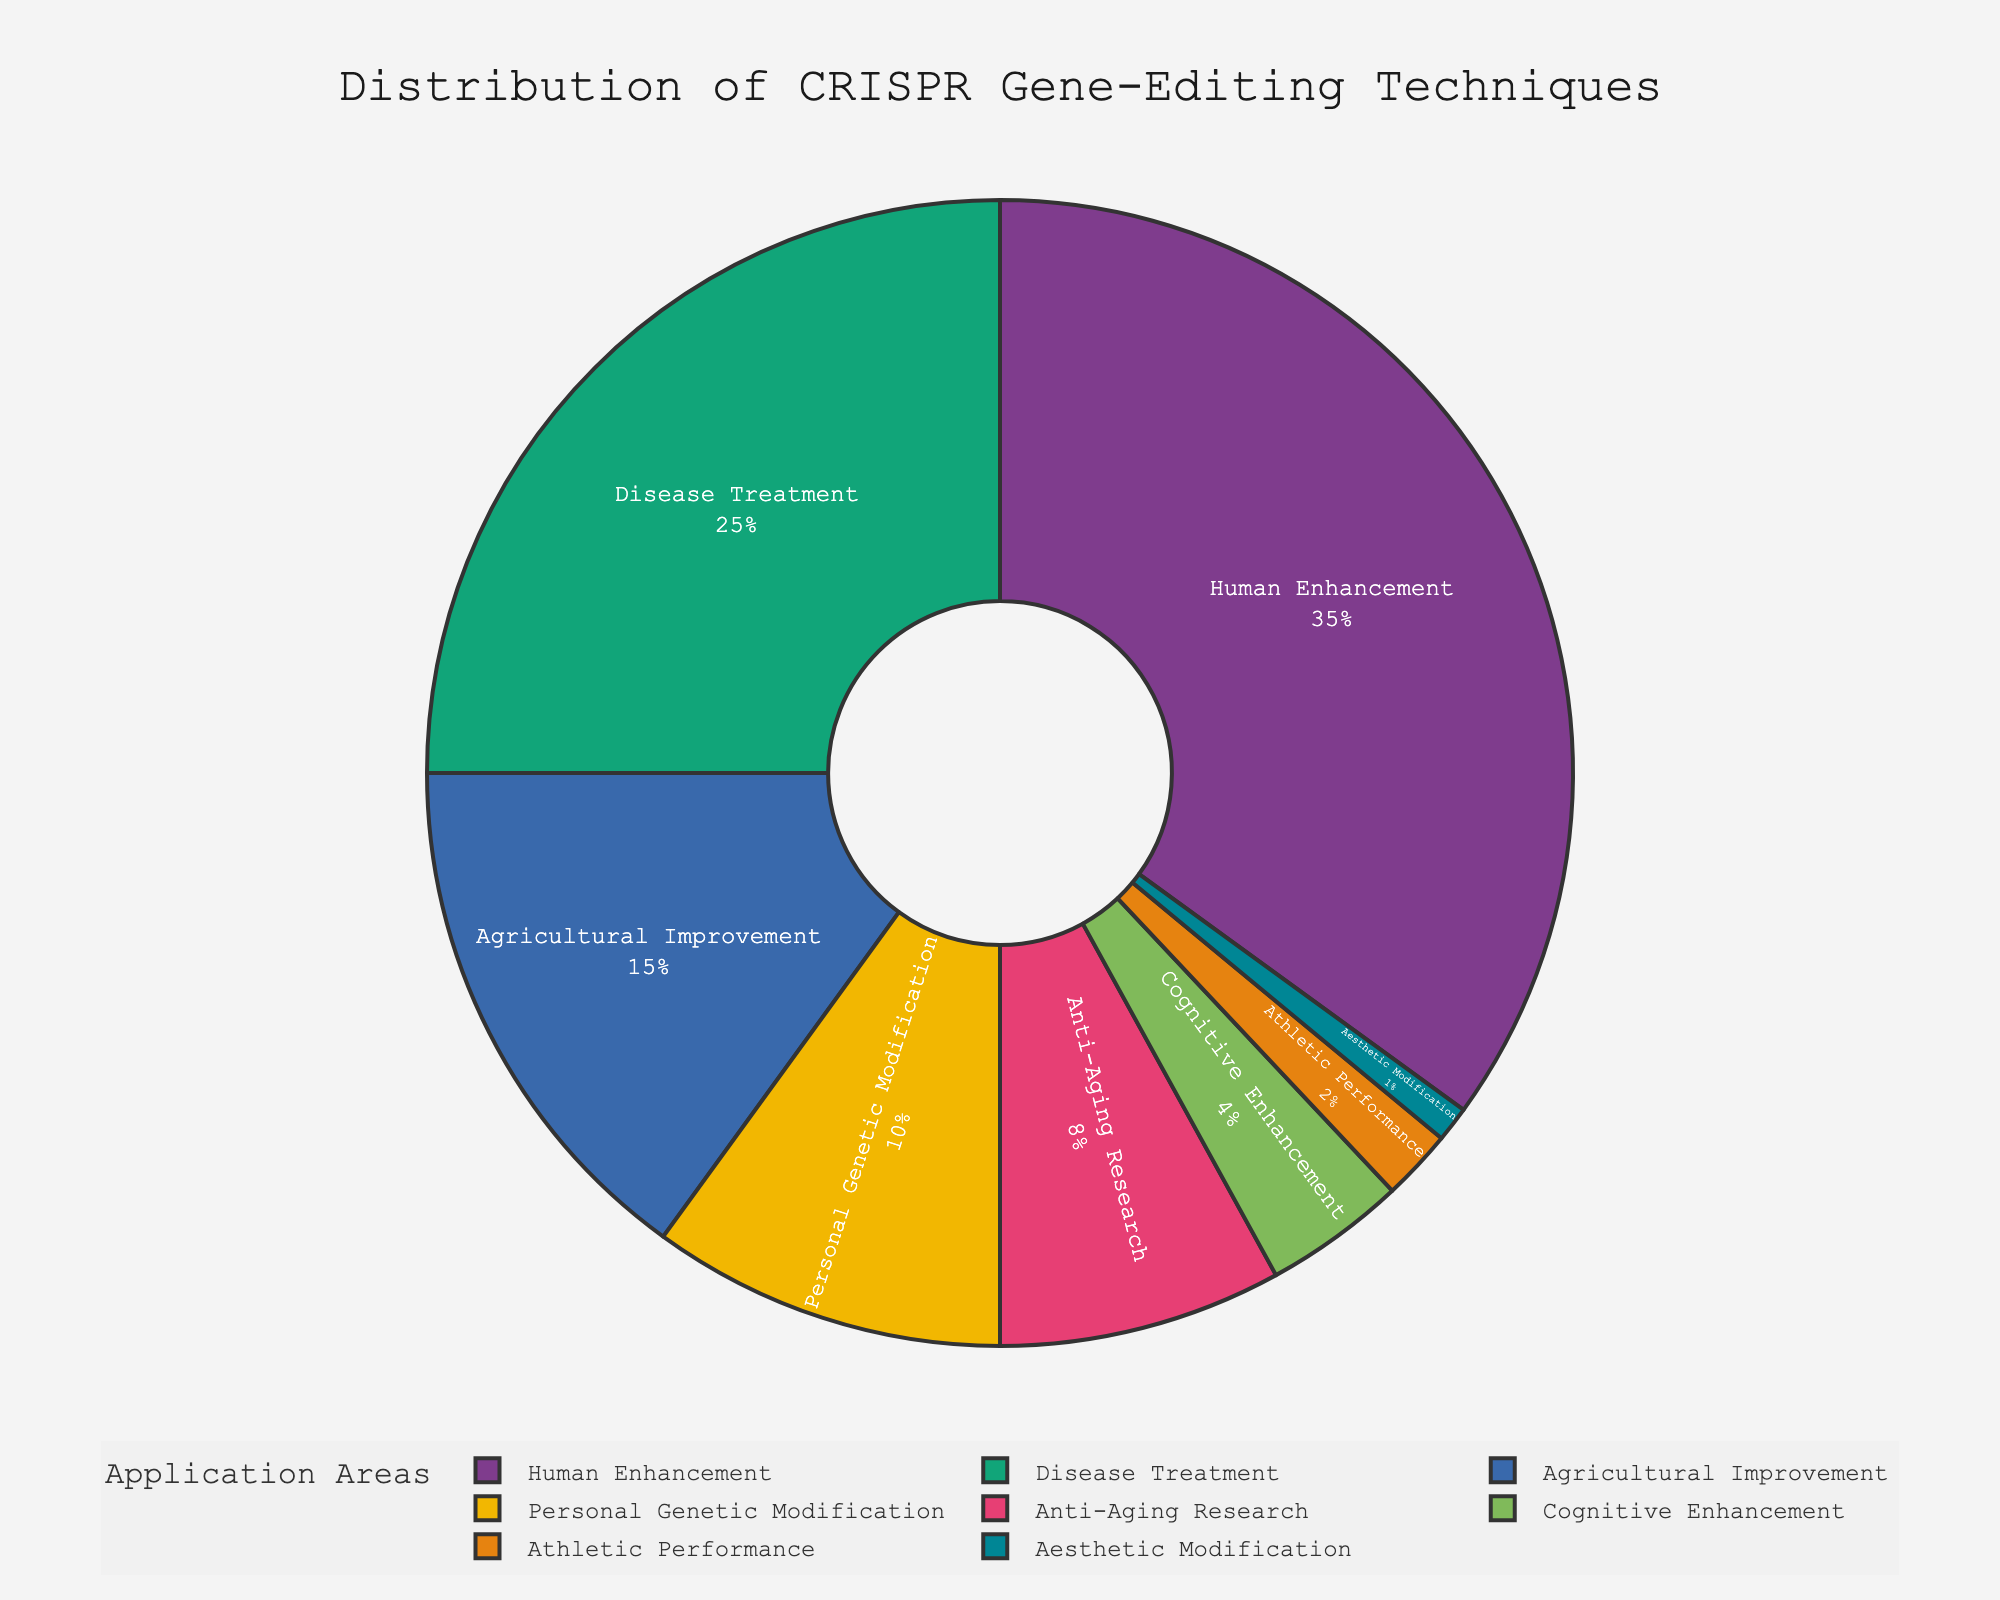What application area in the pie chart has the highest percentage? To determine the application area with the highest percentage, look for the largest segment of the pie chart and read its corresponding label. The largest segment represents 'Human Enhancement' with 35%.
Answer: Human Enhancement Which application areas combined make up less than 10% of the total? Identify the segments in the pie chart labeled with percentages less than 10% and sum their values. The areas are 'Cognitive Enhancement' (4%), 'Athletic Performance' (2%), and 'Aesthetic Modification' (1%). Summing these values yields 4% + 2% + 1% = 7%.
Answer: Cognitive Enhancement, Athletic Performance, Aesthetic Modification How many application areas have a percentage higher than 15%? Count the number of segments in the pie chart that have percentages greater than 15%. These areas are 'Human Enhancement' (35%), 'Disease Treatment' (25%), and 'Agricultural Improvement' (15%).
Answer: 3 What is the combined percentage for 'Disease Treatment' and 'Agricultural Improvement'? Find the segments for 'Disease Treatment' and 'Agricultural Improvement' and add their percentages. 'Disease Treatment' is 25% and 'Agricultural Improvement' is 15%. Summing these, 25% + 15% = 40%.
Answer: 40% Which application area has a lower percentage than 'Anti-Aging Research' but higher than 'Athletic Performance'? Looking at the segments in the pie chart: 'Anti-Aging Research' is 8%, 'Athletic Performance' is 2%, and we need a segment between these percentages. 'Personal Genetic Modification' is 10%, but it is higher than 8%. 'Cognitive Enhancement' is 4%, which fits the criteria.
Answer: Cognitive Enhancement Which two application areas have the smallest and largest percentages respectively? Identify the smallest and largest segments from the pie chart. The smallest segment represents 'Aesthetic Modification' with 1%, and the largest represents 'Human Enhancement' with 35%.
Answer: Aesthetic Modification, Human Enhancement Is the percentage for 'Anti-Aging Research' greater than the sum of 'Athletic Performance' and 'Aesthetic Modification'? Find the values for 'Anti-Aging Research' (8%), 'Athletic Performance' (2%), and 'Aesthetic Modification' (1%). Sum the last two: 2% + 1% = 3%, then compare with 8%. Since 8% > 3%, the statement holds true.
Answer: Yes What is the combined percentage for all application areas? Add all the percentages shown in the pie chart: 35% + 25% + 15% + 10% + 8% + 4% + 2% + 1% = 100%.
Answer: 100% If you remove the 'Human Enhancement' segment, what percentage of the remaining pie chart does 'Disease Treatment' represent? The 'Human Enhancement' segment is 35%. Removing it leaves a total of 100% - 35% = 65%. Then, 'Disease Treatment' represents 25% of the original 100%. To find its new percentage in the remaining pie: (25 / 65) * 100 ≈ 38.46%.
Answer: 38.46% 